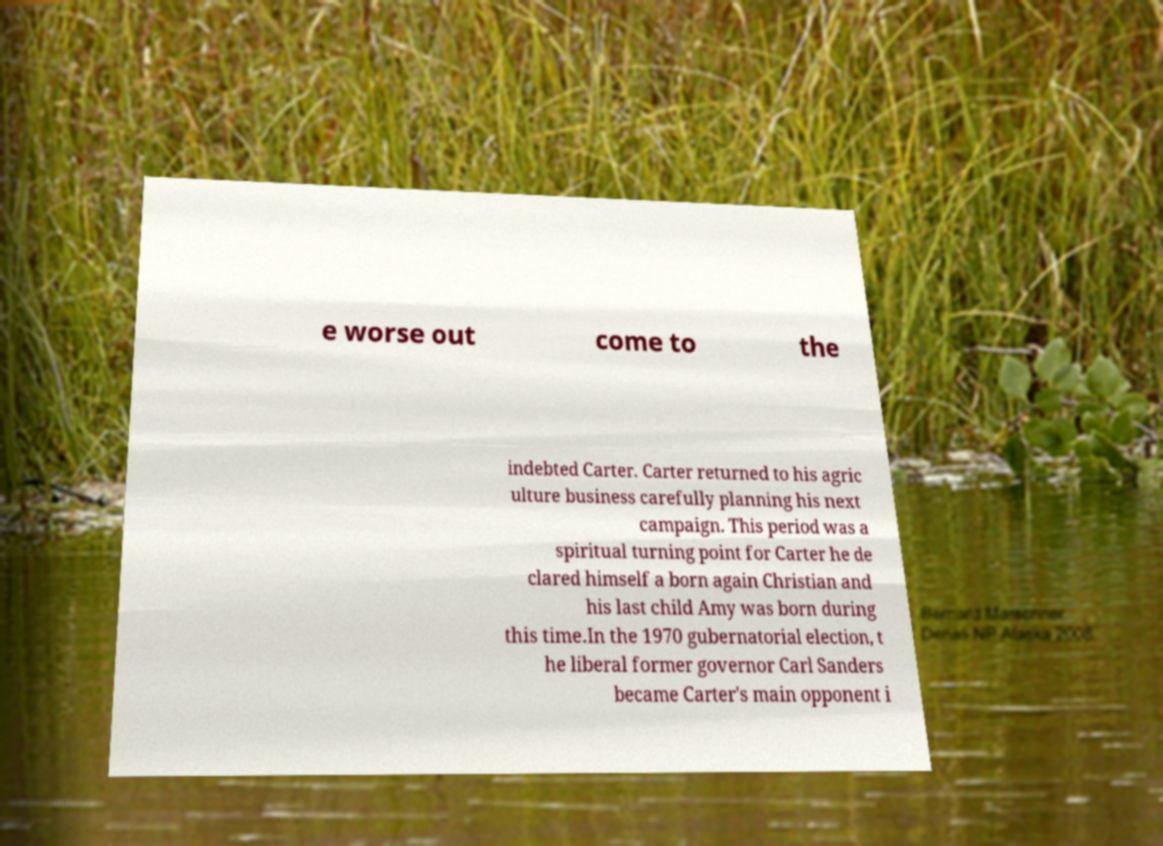Can you read and provide the text displayed in the image?This photo seems to have some interesting text. Can you extract and type it out for me? e worse out come to the indebted Carter. Carter returned to his agric ulture business carefully planning his next campaign. This period was a spiritual turning point for Carter he de clared himself a born again Christian and his last child Amy was born during this time.In the 1970 gubernatorial election, t he liberal former governor Carl Sanders became Carter's main opponent i 